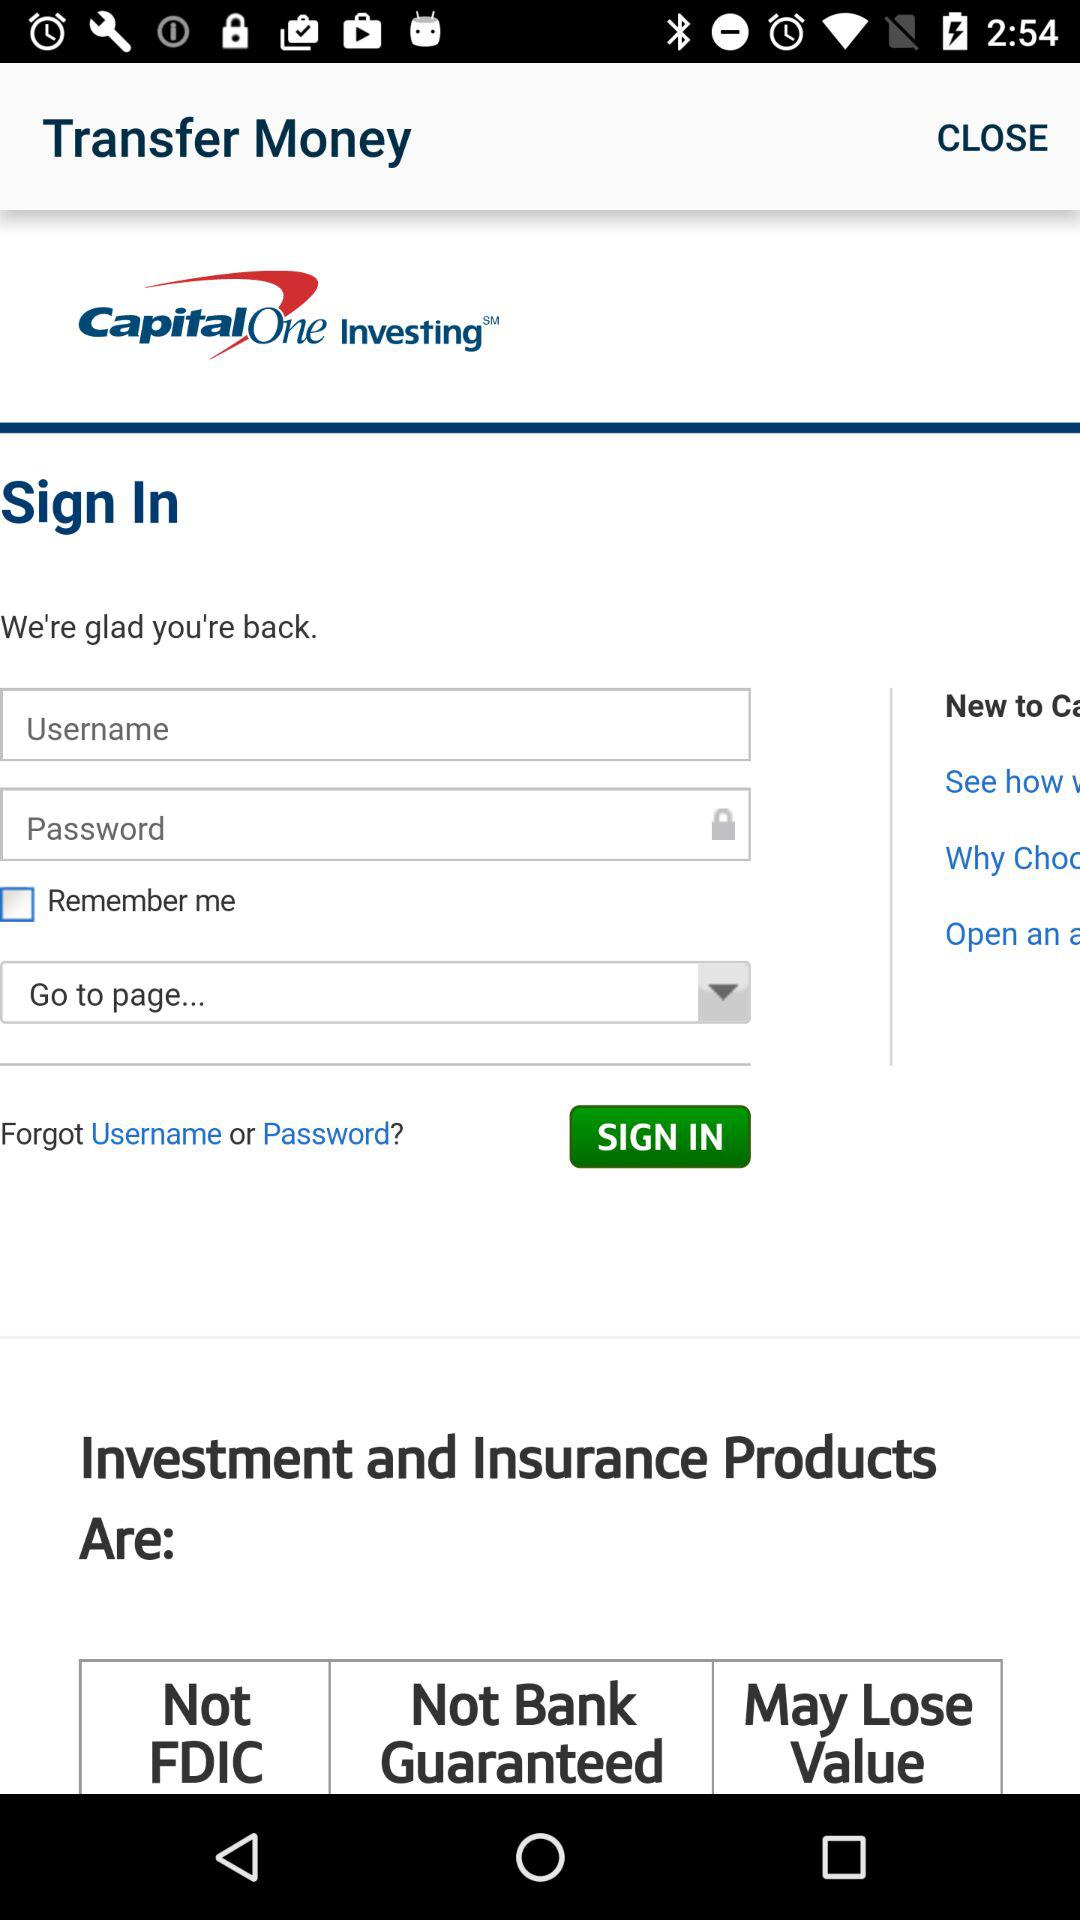What is the application name? The application name is "Capital One". 